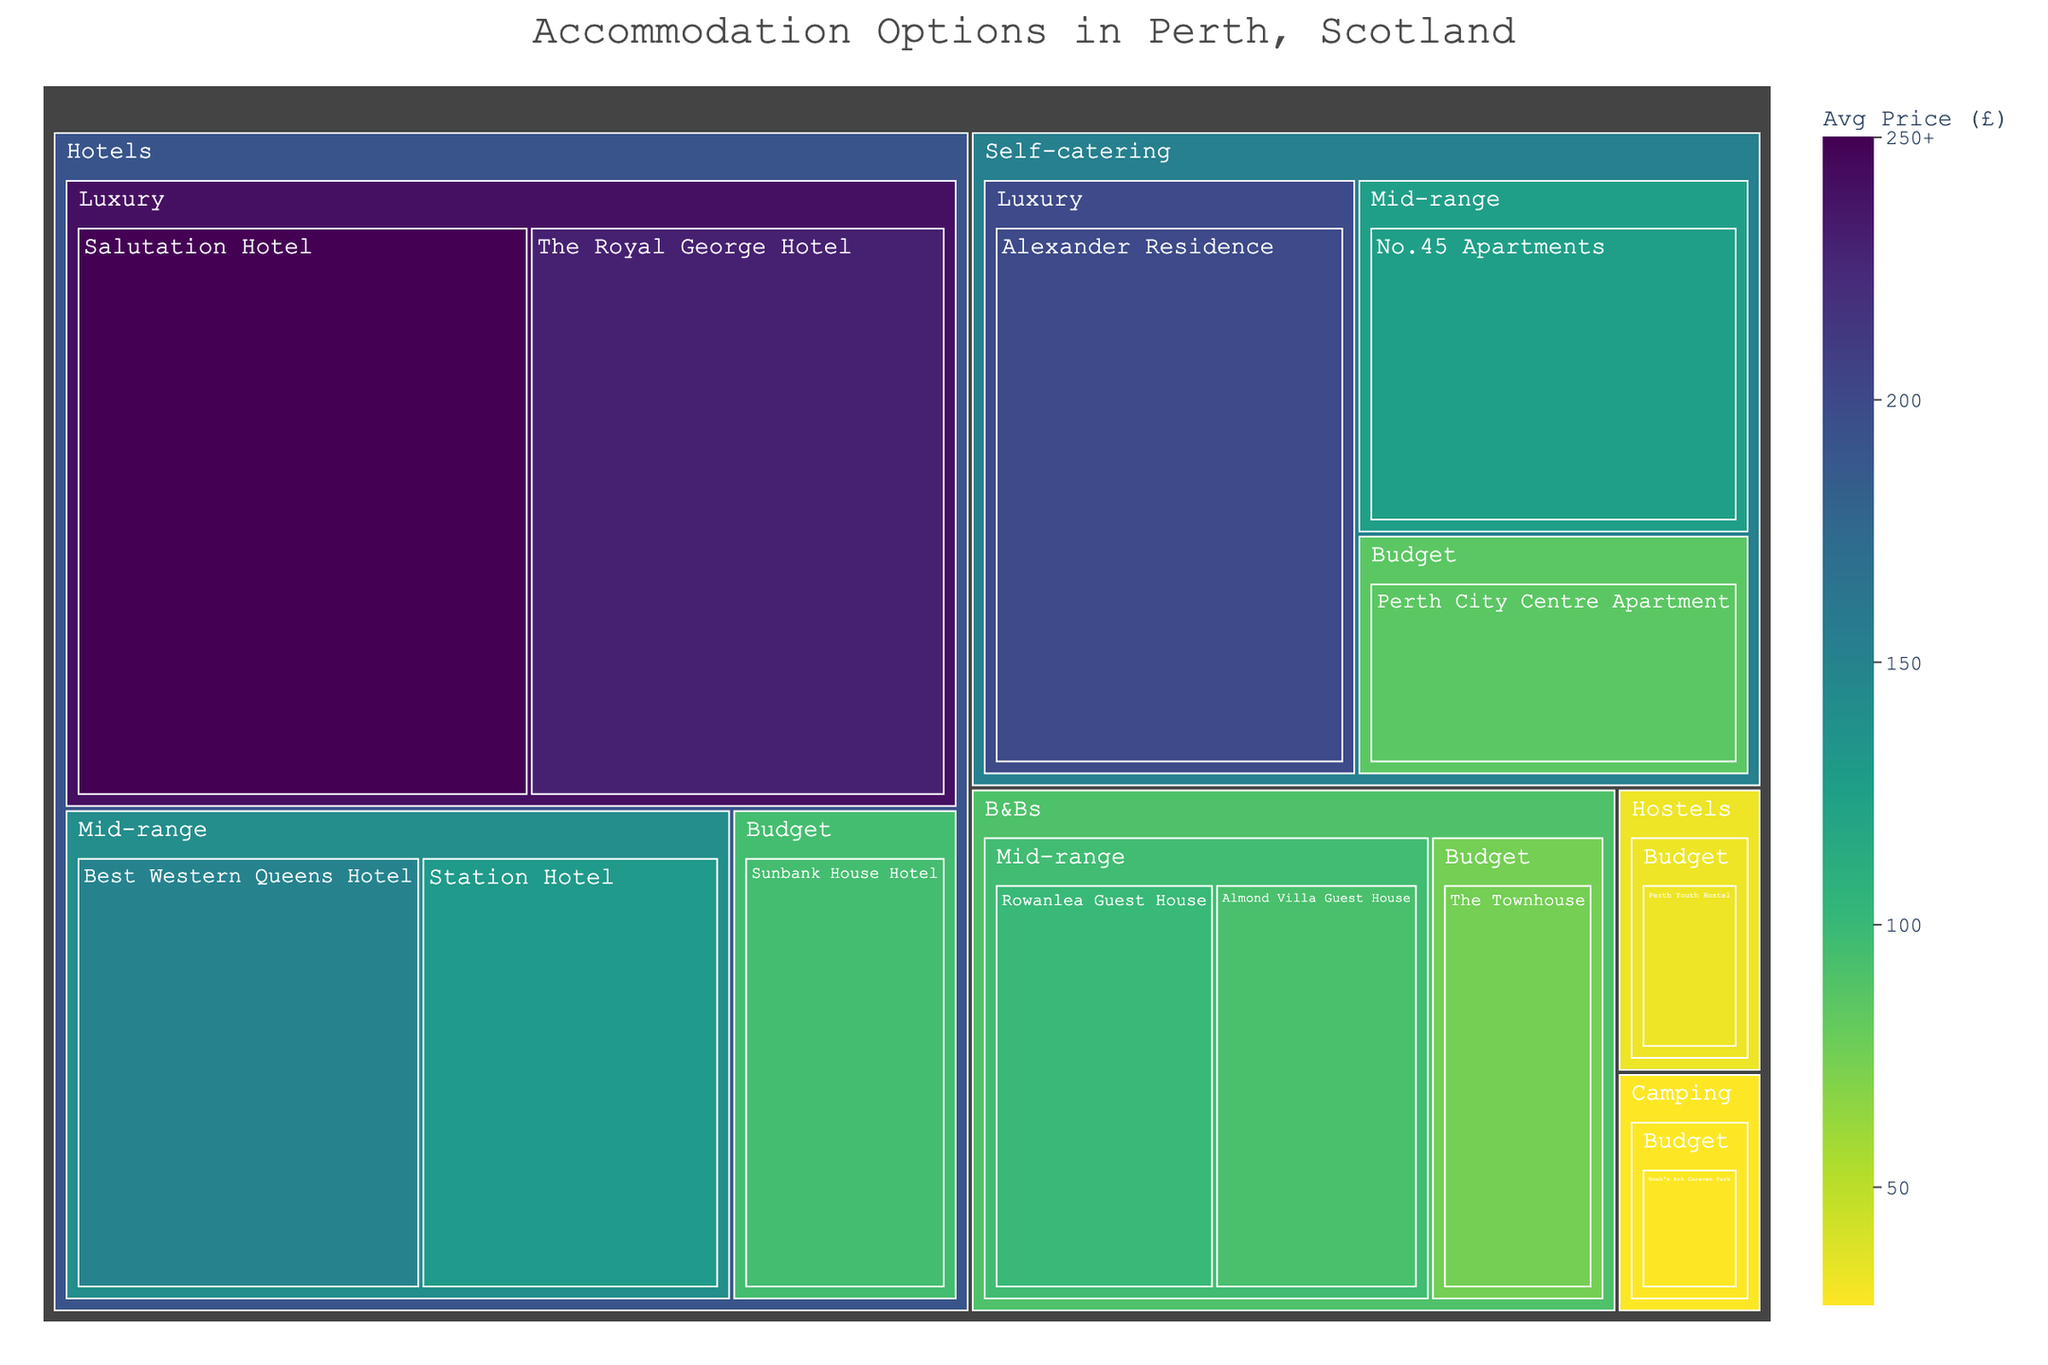How many types of accommodation options are displayed in the figure? The treemap shows the main categories of accommodation types. By counting the top-level categories, we find the number of distinct accommodation types.
Answer: 5 What is the average price range for the Luxury category within Hotels? The Luxury category under Hotels includes "Salutation Hotel" (£200-300) and "The Royal George Hotel" (£180-280). Calculate the average for each: (200+300)/2 = 250 and (180+280)/2 = 230, then find the average of these averages: (250+230)/2 = 240.
Answer: £240 Which type of accommodation has the lowest average price? By observing the color scale and labels, identify the category with the darkest shading (indicating a lower average price). "Camping" with "Noah's Ark Caravan Park" (£20-35) has the lowest average price calculated as (20+35)/2 = 27.5.
Answer: Camping If you want to stay in a Mid-range price accommodation, which one has the highest average price? Among the Mid-range options available, compare the average prices: "Best Western Queens Hotel" (150), "Station Hotel" (130), "Rowanlea Guest House" (100), "Almond Villa Guest House" (92.5), "No.45 Apartments" (125). The highest among them is "Best Western Queens Hotel".
Answer: Best Western Queens Hotel What is the spread of average prices within B&Bs? Calculate the differences in average prices within B&Bs: "Rowanlea Guest House" (100), "Almond Villa Guest House" (92.5), "The Townhouse" (75). The spread is highest (100-75) and lowest (100-92.5).
Answer: £25 Which accommodation type has the widest price range? Look at the labels and price ranges for each accommodation, then identify the one with the largest numerical difference: "Salutation Hotel" has the range £200-300 (100), "The Royal George Hotel" has £180-280 (100), and "Alexander Residence" has £150-250 (100). All others have smaller ranges.
Answer: Hotels (Luxury) and Self-catering (Luxury) What is the total number of accommodation options available in Perth? By counting all individual names within the treemap, we get the total number of options: Salutation Hotel, The Royal George Hotel, Best Western Queens Hotel, Station Hotel, Sunbank House Hotel, Rowanlea Guest House, Almond Villa Guest House, The Townhouse, Alexander Residence, No.45 Apartments, Perth City Centre Apartment, Perth Youth Hostel, Noah’s Ark Caravan Park.
Answer: 13 Which hotel offers accommodation with the highest average price? Within the Hotels category, compare the average prices of each option: "Salutation Hotel" (250) and "The Royal George Hotel" (230), the highest is "Salutation Hotel".
Answer: Salutation Hotel How many options are available within the Budget price range? Count the individual names under the Budget category across all accommodation types visible in the treemap: "Sunbank House Hotel", "The Townhouse", "Perth City Centre Apartment", "Perth Youth Hostel", and "Noah's Ark Caravan Park".
Answer: 5 